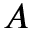Convert formula to latex. <formula><loc_0><loc_0><loc_500><loc_500>A</formula> 